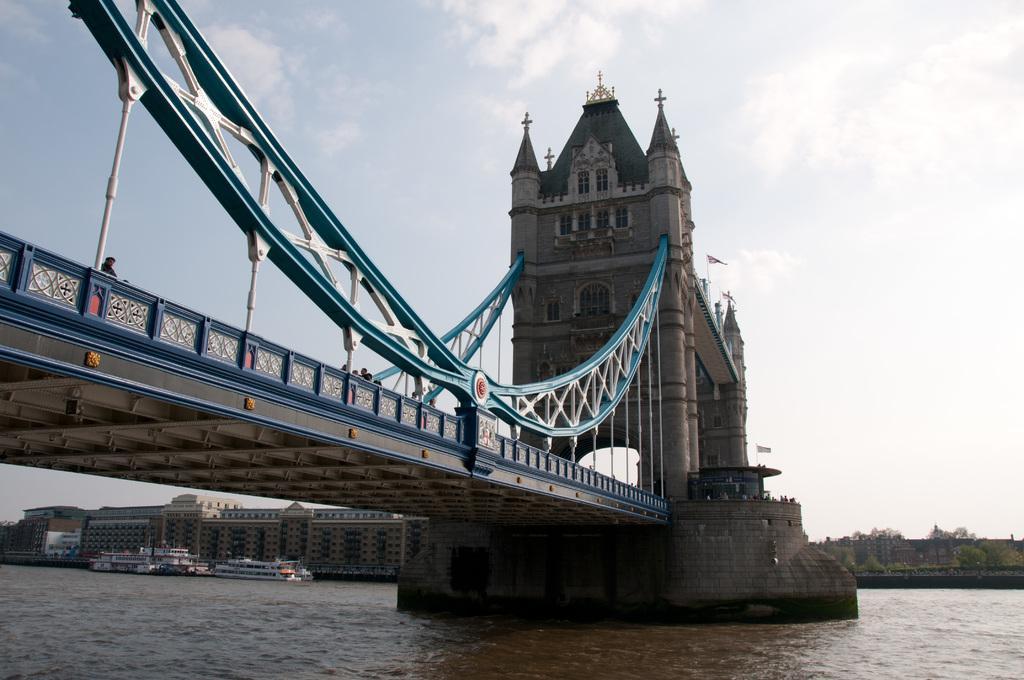How would you summarize this image in a sentence or two? In the image there is a bridge on the left side with a sea below it, in the background there are buildings on the left and trees on the right side and above its sky with clouds. 